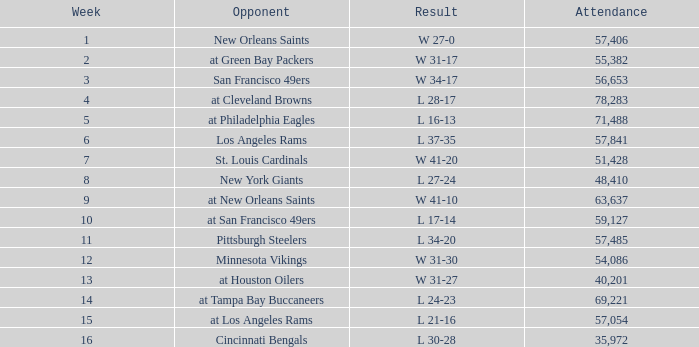What was the typical attendance count for the game on november 29, 1981, after week 13? None. 